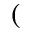Convert formula to latex. <formula><loc_0><loc_0><loc_500><loc_500>(</formula> 